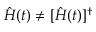<formula> <loc_0><loc_0><loc_500><loc_500>\hat { H } ( t ) \neq [ \hat { H } ( t ) ] ^ { \dagger }</formula> 